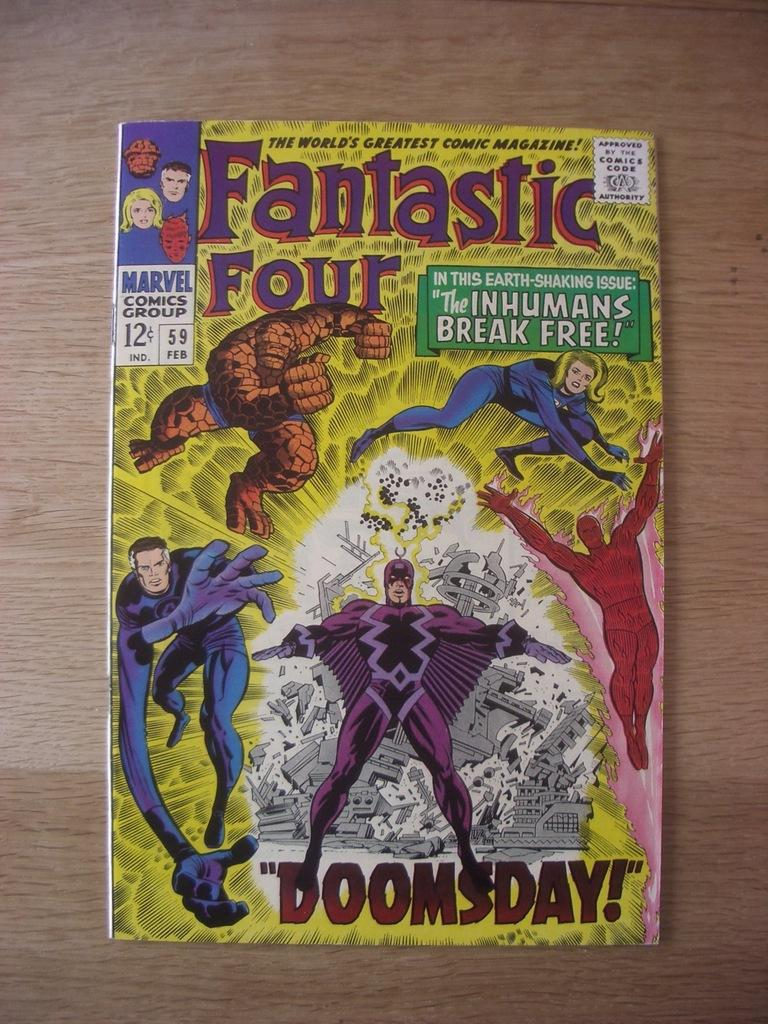<image>
Give a short and clear explanation of the subsequent image. A Fantastic Four comic is on a wooden table. 